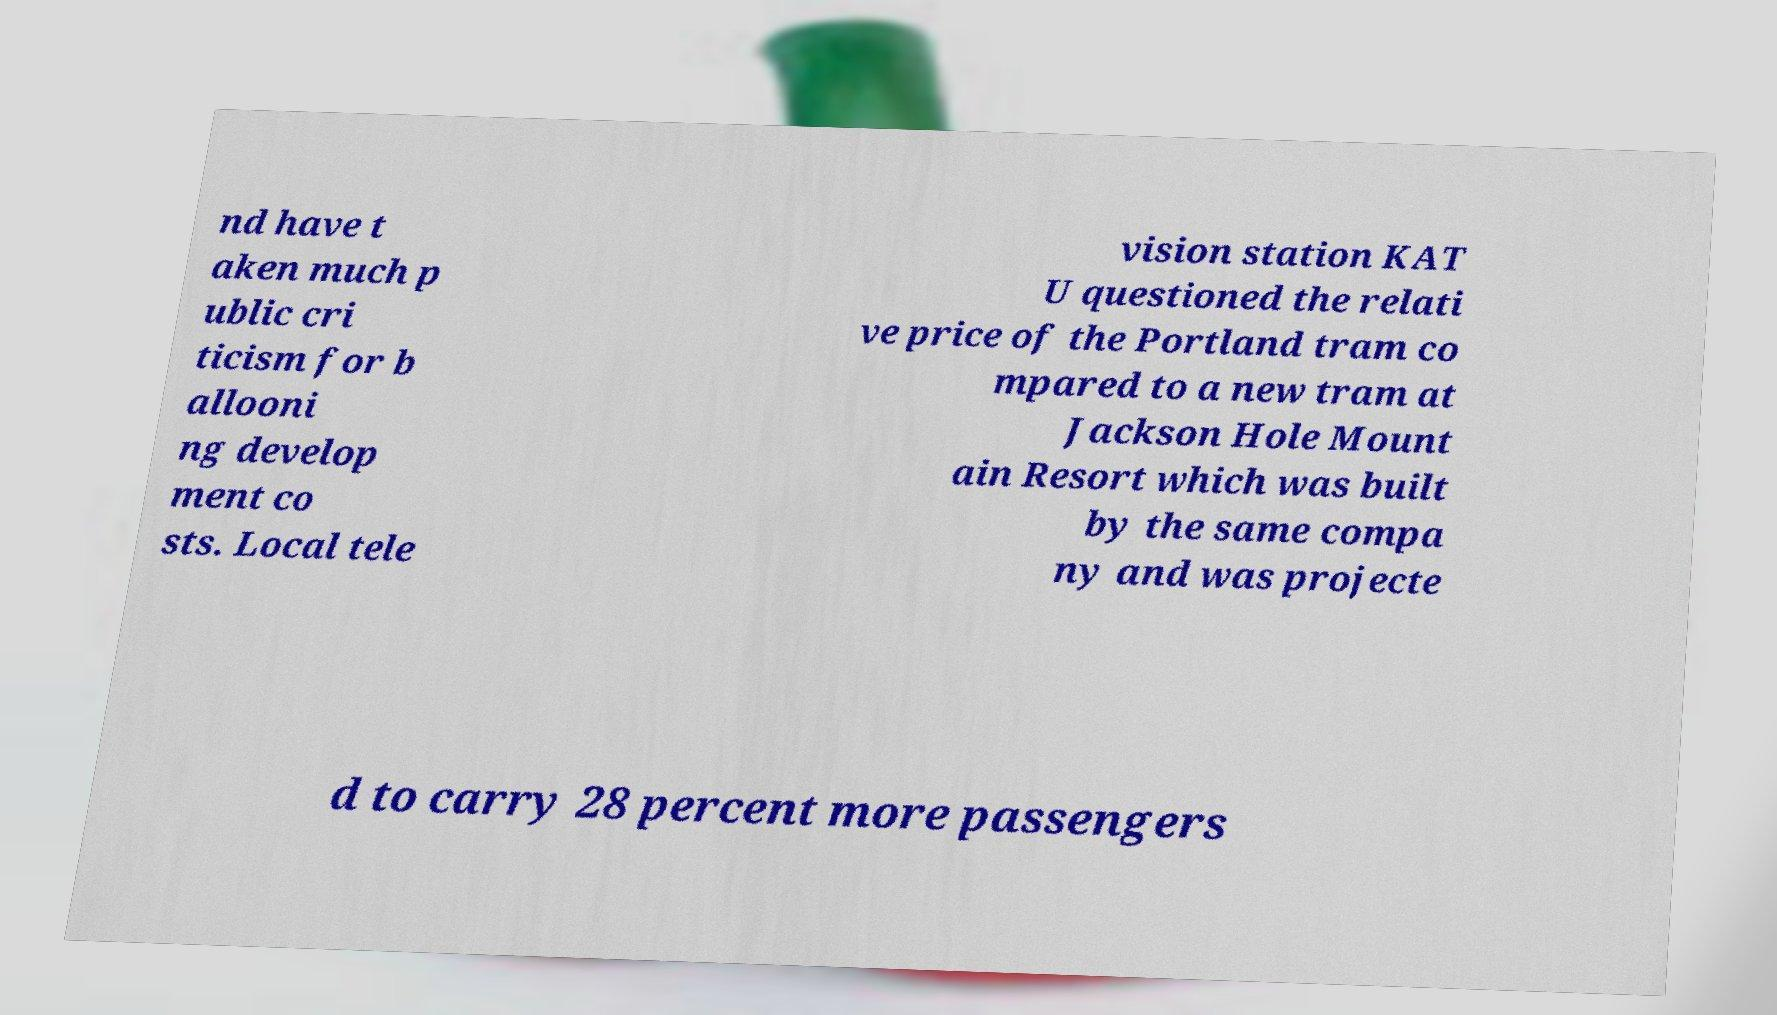Can you accurately transcribe the text from the provided image for me? nd have t aken much p ublic cri ticism for b allooni ng develop ment co sts. Local tele vision station KAT U questioned the relati ve price of the Portland tram co mpared to a new tram at Jackson Hole Mount ain Resort which was built by the same compa ny and was projecte d to carry 28 percent more passengers 